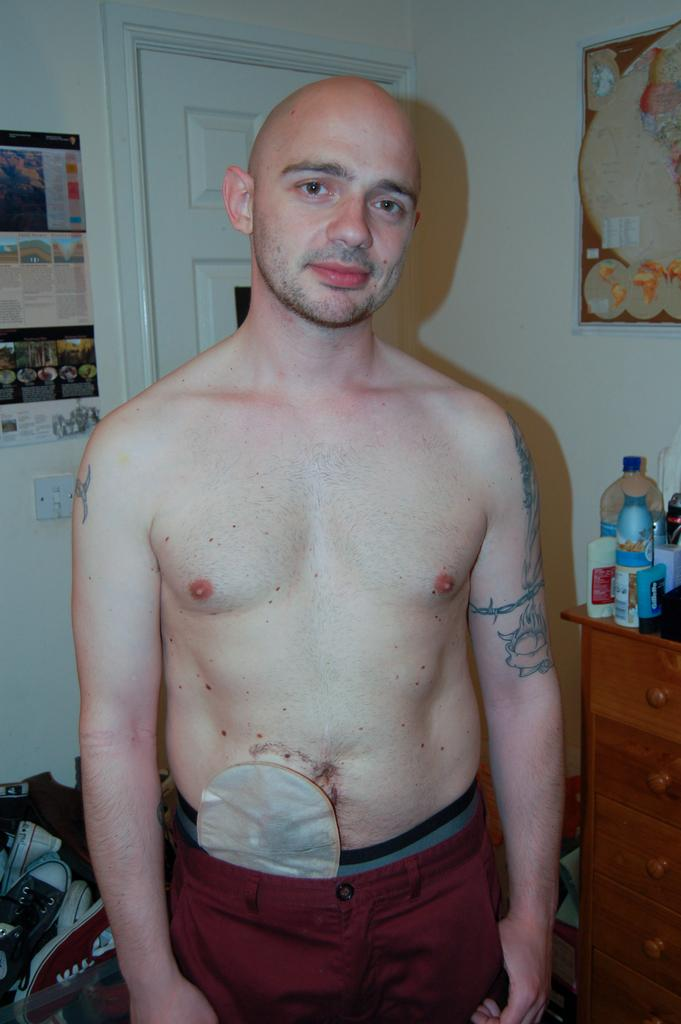Who is the main subject in the image? There is a man in the middle of the image. What objects are on the table behind the man? There are shots and bottles on the table behind the man. What can be seen on the wall in the background of the image? There are posts on the wall in the background of the image. What is the man thinking about in the image? The image does not provide any information about the man's thoughts or mental state, so we cannot determine what he might be thinking about. 